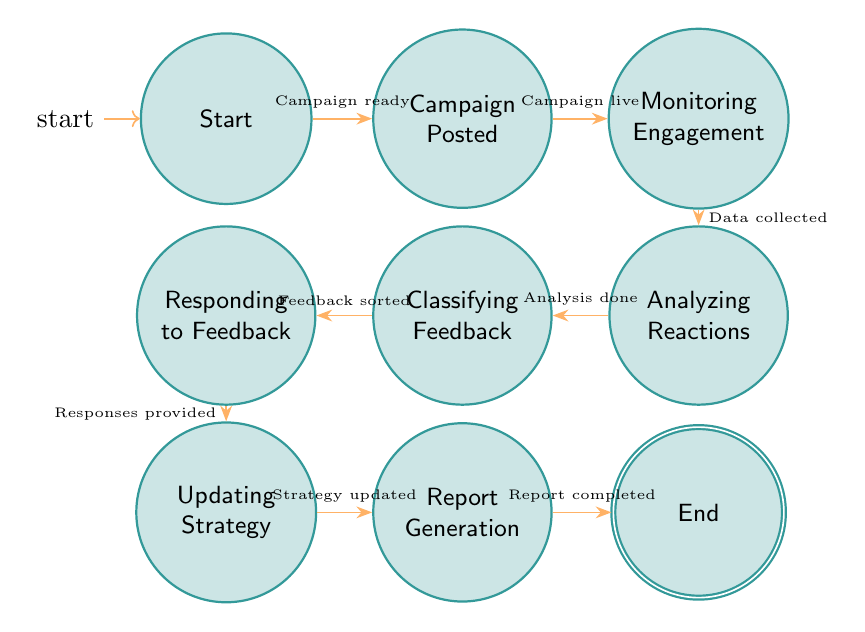What is the initial state of the campaign process? The diagram indicates that the initial state, labeled as "Start," is where the campaign is launched.
Answer: Start How many states are present in the diagram? By counting the separate nodes or states shown in the diagram, there are a total of nine states representing different stages of the campaign.
Answer: Nine What transition occurs after the campaign is posted? The transition occurs from "Campaign Posted" to "Monitoring Engagement," indicating that the campaign is now live.
Answer: Monitoring Engagement What is the condition for moving from "Analyzing Reactions" to "Classifying Feedback"? The transition from "Analyzing Reactions" to "Classifying Feedback" occurs when sentiment analysis is completed, providing a basis for classification.
Answer: Sentiment analysis completed Which state follows "Updating Strategy"? According to the diagram, the state that follows "Updating Strategy" is "Report Generation," suggesting the flow from adjusting the strategy to creating a report on performance.
Answer: Report Generation What is the final state of the campaign response process? The last state in the campaign flow is labeled as "End," signifying the completion of the analysis.
Answer: End Which state requires sufficient engagement data to proceed? The transition occurs from "Monitoring Engagement" to "Analyzing Reactions," indicating that sufficient engagement data must be collected for further analysis.
Answer: Analyzing Reactions How many transitions are detailed in the diagram? The diagram illustrates a sequence of eight transitions connecting the states, detailing the steps in the campaign's response analysis process.
Answer: Eight What must happen for feedback to be classified? Feedback classification occurs once the sentiment analysis is completed, providing the necessary insights for organizing the feedback.
Answer: Feedback classified 